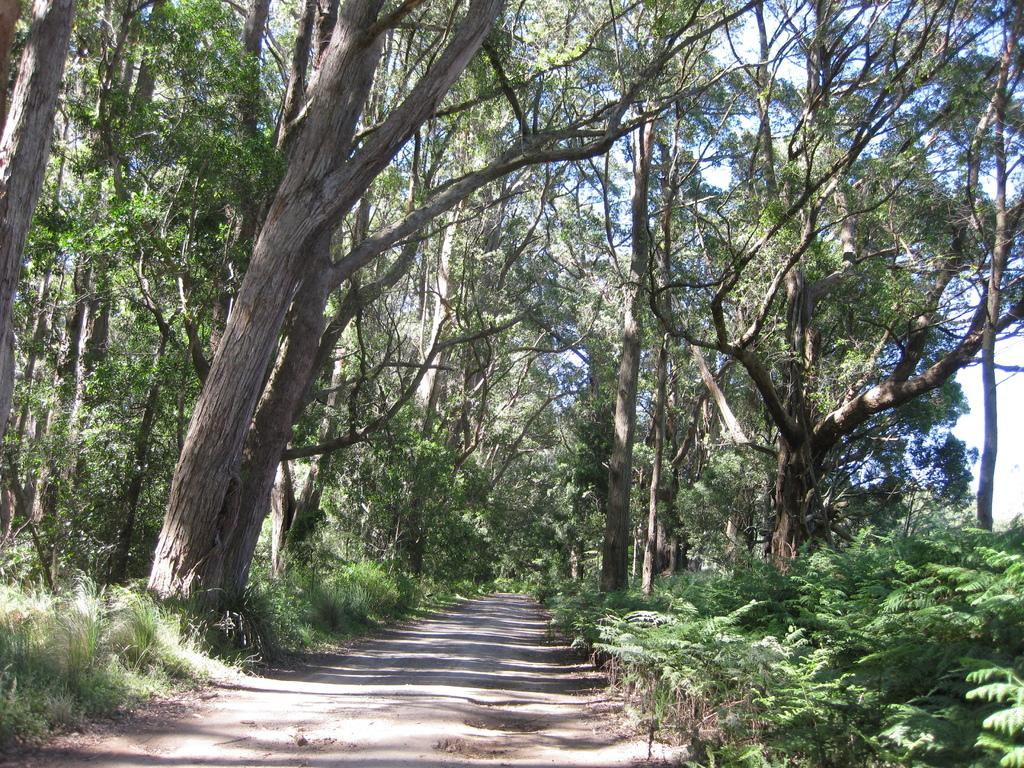What type of vegetation can be seen in the image? There is grass, plants, and trees in the image. What part of the natural environment is visible in the image? The sky is visible in the background of the image. What type of skirt is the doctor wearing while performing an activity in the image? There is no doctor, skirt, or activity present in the image. 